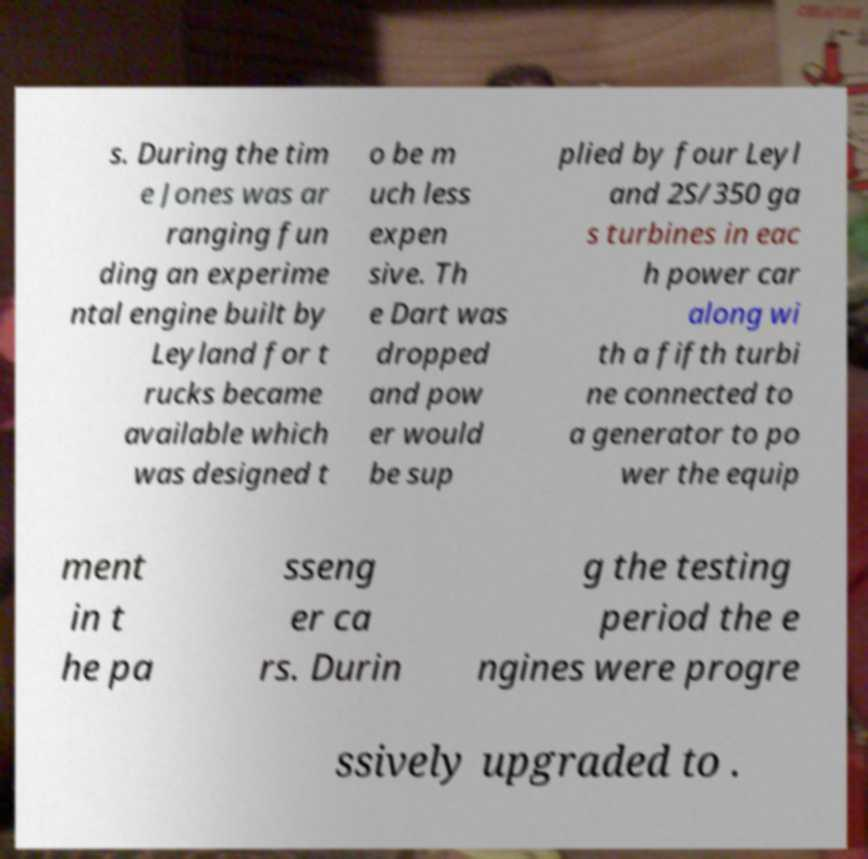I need the written content from this picture converted into text. Can you do that? s. During the tim e Jones was ar ranging fun ding an experime ntal engine built by Leyland for t rucks became available which was designed t o be m uch less expen sive. Th e Dart was dropped and pow er would be sup plied by four Leyl and 2S/350 ga s turbines in eac h power car along wi th a fifth turbi ne connected to a generator to po wer the equip ment in t he pa sseng er ca rs. Durin g the testing period the e ngines were progre ssively upgraded to . 